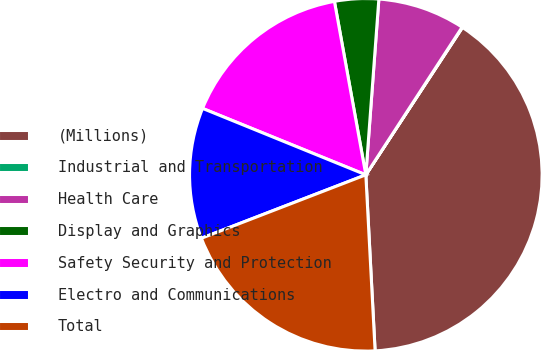<chart> <loc_0><loc_0><loc_500><loc_500><pie_chart><fcel>(Millions)<fcel>Industrial and Transportation<fcel>Health Care<fcel>Display and Graphics<fcel>Safety Security and Protection<fcel>Electro and Communications<fcel>Total<nl><fcel>39.93%<fcel>0.04%<fcel>8.02%<fcel>4.03%<fcel>16.0%<fcel>12.01%<fcel>19.98%<nl></chart> 